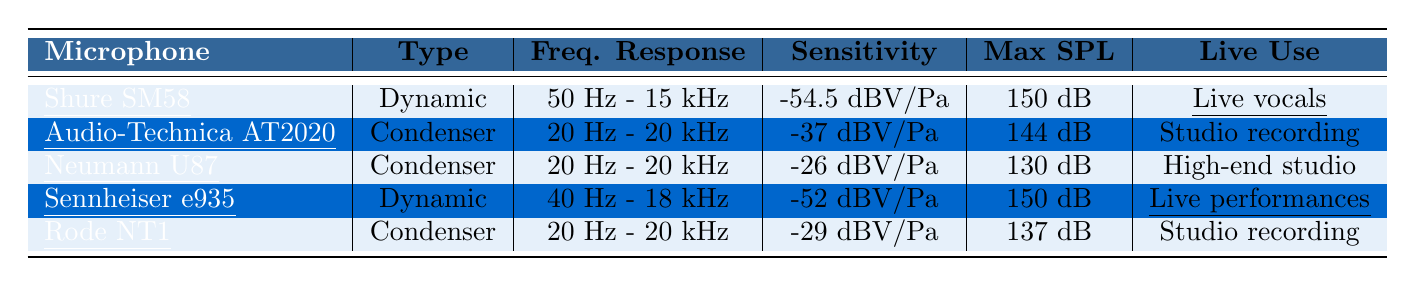What is the frequency response of the Shure SM58? The Shure SM58 has a frequency response listed in the table as "50 Hz - 15 kHz."
Answer: 50 Hz - 15 kHz Which microphone has the highest sensitivity? From the table, the microphone with the highest sensitivity is the Audio-Technica AT2020, with a sensitivity of "-37 dBV/Pa."
Answer: Audio-Technica AT2020 How many of the microphones are dynamic? There are 2 dynamic microphones listed in the table (Shure SM58 and Sennheiser e935).
Answer: 2 What is the common use for the Neumann U87? The common use for the Neumann U87, according to the table, is "High-end studio recording."
Answer: High-end studio recording Which microphone has the lowest max input sound level? The microphone with the lowest max input sound level is the Neumann U87, listed as "130 dB SPL."
Answer: Neumann U87 Is the wind shield included with the Audio-Technica AT2020? According to the table, the Audio-Technica AT2020 has an "Optional" wind shield, meaning it is not included by default.
Answer: No What is the average durability rating of the dynamic microphones? The average durability rating is calculated as (4.9 + 4.7) / 2 = 4.8 for the two dynamic microphones (Shure SM58 and Sennheiser e935).
Answer: 4.8 Which microphone is best for live performances based on feedback rejection? Based on feedback rejection in the table, both Shure SM58 and Sennheiser e935 have "High" feedback rejection, making them suitable for live performances.
Answer: Shure SM58 and Sennheiser e935 What type of microphone is the Rode NT1? The Rode NT1 is classified as a "Condenser" microphone in the table.
Answer: Condenser Which microphone has the highest average durability rating? The microphone with the highest average durability rating is the Shure SM58, with a rating of "4.9/5."
Answer: Shure SM58 